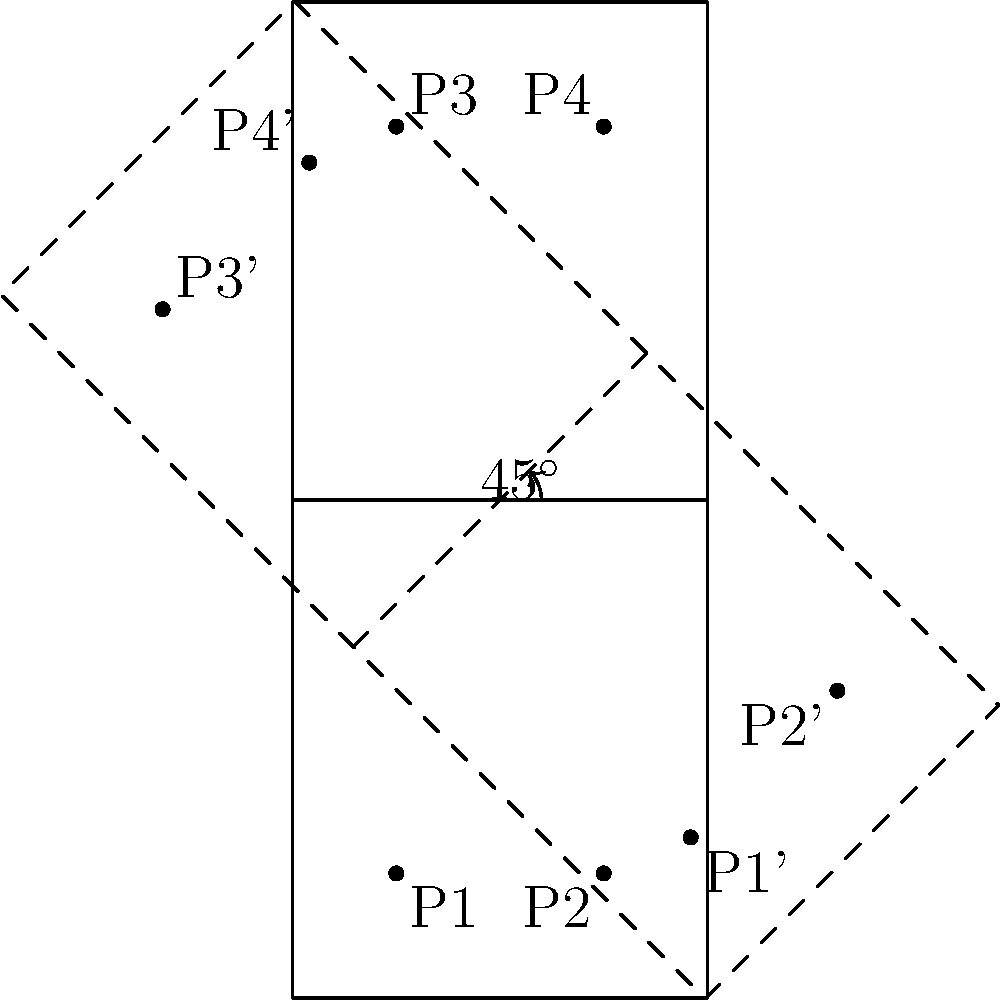In a doubles tennis match, the court and player positions have been rotated $45^\circ$ clockwise around the center of the court. If player P1's original position was $(2.5, 3)$, what are the coordinates of P1's new position (P1') after the rotation? Round your answer to two decimal places. To find the new coordinates of P1 after rotation, we'll follow these steps:

1) The center of rotation is the center of the court: $(5, 12)$.

2) We'll use the rotation formula:
   $x' = (x - x_c)\cos\theta - (y - y_c)\sin\theta + x_c$
   $y' = (x - x_c)\sin\theta + (y - y_c)\cos\theta + y_c$

   Where $(x, y)$ is the original point, $(x_c, y_c)$ is the center of rotation, and $\theta$ is the angle of rotation.

3) Our values are:
   $x = 2.5$, $y = 3$
   $x_c = 5$, $y_c = 12$
   $\theta = -45^\circ$ (negative because it's clockwise)

4) Let's calculate:
   $x' = (2.5 - 5)\cos(-45^\circ) - (3 - 12)\sin(-45^\circ) + 5$
   $y' = (2.5 - 5)\sin(-45^\circ) + (3 - 12)\cos(-45^\circ) + 12$

5) Simplify:
   $x' = (-2.5 \cdot \frac{\sqrt{2}}{2}) - (9 \cdot \frac{\sqrt{2}}{2}) + 5$
   $y' = (-2.5 \cdot \frac{\sqrt{2}}{2}) + (9 \cdot \frac{\sqrt{2}}{2}) + 12$

6) Calculate:
   $x' \approx 6.77$
   $y' \approx 8.23$

7) Rounding to two decimal places:
   $x' = 6.77$
   $y' = 8.23$
Answer: $(6.77, 8.23)$ 